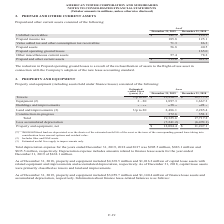According to American Tower Corporation's financial document, What were the unbilled receivables in 2019? According to the financial document, $142.3 (in millions). The relevant text states: "Unbilled receivables $ 142.3 $ 126.1 Prepaid income tax 185.8 125.1..." Also, What was the Prepaid income tax in 2018? According to the financial document, 125.1 (in millions). The relevant text states: "eivables $ 142.3 $ 126.1 Prepaid income tax 185.8 125.1..." Also, Why was there a reduction in prepaid operating ground leases? reclassification of assets to the Right-of-use asset in connection with the Company’s adoption of the new lease accounting standard.. The document states: "Prepaid operating ground leases is a result of the reclassification of assets to the Right-of-use asset in connection with the Company’s adoption of t..." Also, can you calculate: What was the change in Unbilled receivables between 2018 and 2019? Based on the calculation: $142.3-$126.1, the result is 16.2 (in millions). This is based on the information: "Unbilled receivables $ 142.3 $ 126.1 Prepaid income tax 185.8 125.1 Unbilled receivables $ 142.3 $ 126.1 Prepaid income tax 185.8 125.1..." The key data points involved are: 126.1, 142.3. Also, can you calculate: What was the change in prepaid assets between 2018 and 2019? Based on the calculation: 56.8-40.5, the result is 16.3 (in millions). This is based on the information: "ion tax receivables 71.3 86.3 Prepaid assets 56.8 40.5 sumption tax receivables 71.3 86.3 Prepaid assets 56.8 40.5..." The key data points involved are: 40.5, 56.8. Also, can you calculate: What was the percentage change in Prepaid and other current assets between 2018 and 2019? To answer this question, I need to perform calculations using the financial data. The calculation is: ($513.6-$621.2)/$621.2, which equals -17.32 (percentage). This is based on the information: "Prepaid and other current assets $ 513.6 $ 621.2 Prepaid and other current assets $ 513.6 $ 621.2..." The key data points involved are: 513.6, 621.2. 